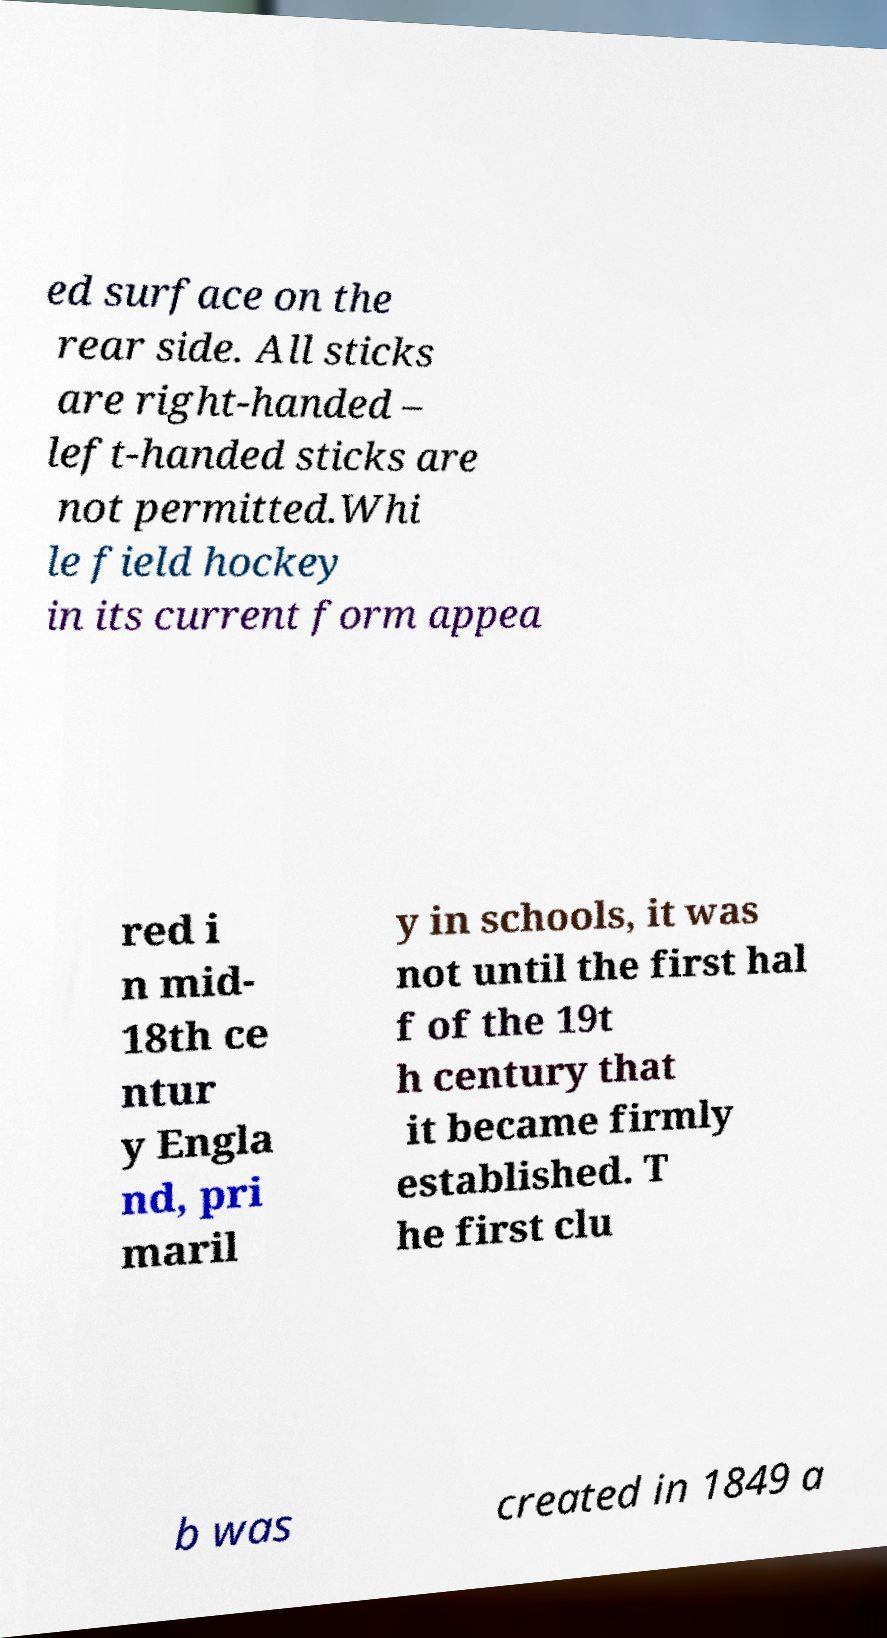Could you extract and type out the text from this image? ed surface on the rear side. All sticks are right-handed – left-handed sticks are not permitted.Whi le field hockey in its current form appea red i n mid- 18th ce ntur y Engla nd, pri maril y in schools, it was not until the first hal f of the 19t h century that it became firmly established. T he first clu b was created in 1849 a 